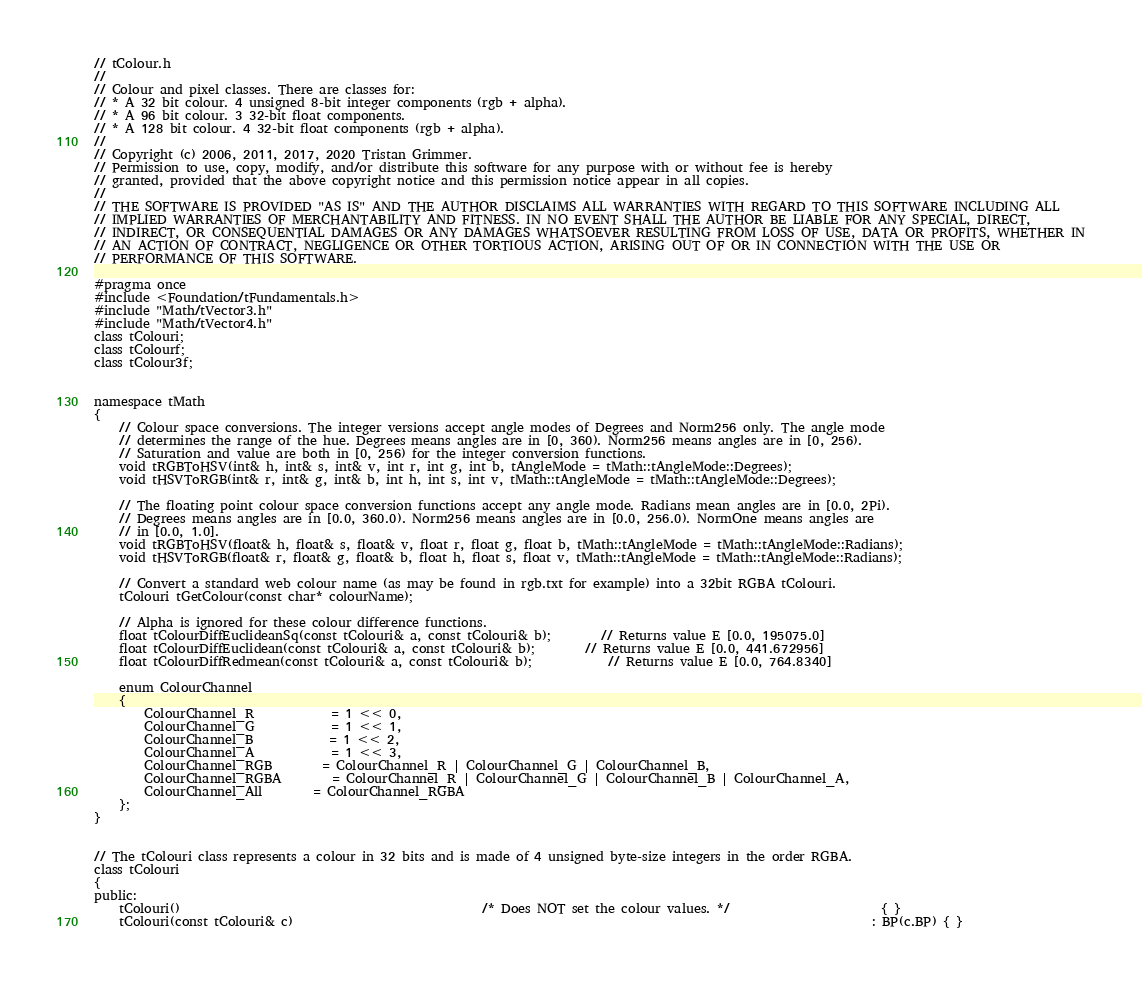<code> <loc_0><loc_0><loc_500><loc_500><_C_>// tColour.h
//
// Colour and pixel classes. There are classes for:
// * A 32 bit colour. 4 unsigned 8-bit integer components (rgb + alpha).
// * A 96 bit colour. 3 32-bit float components.
// * A 128 bit colour. 4 32-bit float components (rgb + alpha).
//
// Copyright (c) 2006, 2011, 2017, 2020 Tristan Grimmer.
// Permission to use, copy, modify, and/or distribute this software for any purpose with or without fee is hereby
// granted, provided that the above copyright notice and this permission notice appear in all copies.
//
// THE SOFTWARE IS PROVIDED "AS IS" AND THE AUTHOR DISCLAIMS ALL WARRANTIES WITH REGARD TO THIS SOFTWARE INCLUDING ALL
// IMPLIED WARRANTIES OF MERCHANTABILITY AND FITNESS. IN NO EVENT SHALL THE AUTHOR BE LIABLE FOR ANY SPECIAL, DIRECT,
// INDIRECT, OR CONSEQUENTIAL DAMAGES OR ANY DAMAGES WHATSOEVER RESULTING FROM LOSS OF USE, DATA OR PROFITS, WHETHER IN
// AN ACTION OF CONTRACT, NEGLIGENCE OR OTHER TORTIOUS ACTION, ARISING OUT OF OR IN CONNECTION WITH THE USE OR
// PERFORMANCE OF THIS SOFTWARE.

#pragma once
#include <Foundation/tFundamentals.h>
#include "Math/tVector3.h"
#include "Math/tVector4.h"
class tColouri;
class tColourf;
class tColour3f;


namespace tMath
{
	// Colour space conversions. The integer versions accept angle modes of Degrees and Norm256 only. The angle mode
	// determines the range of the hue. Degrees means angles are in [0, 360). Norm256 means angles are in [0, 256).
	// Saturation and value are both in [0, 256) for the integer conversion functions.
	void tRGBToHSV(int& h, int& s, int& v, int r, int g, int b, tAngleMode = tMath::tAngleMode::Degrees);
	void tHSVToRGB(int& r, int& g, int& b, int h, int s, int v, tMath::tAngleMode = tMath::tAngleMode::Degrees);

	// The floating point colour space conversion functions accept any angle mode. Radians mean angles are in [0.0, 2Pi).
	// Degrees means angles are in [0.0, 360.0). Norm256 means angles are in [0.0, 256.0). NormOne means angles are
	// in [0.0, 1.0].
	void tRGBToHSV(float& h, float& s, float& v, float r, float g, float b, tMath::tAngleMode = tMath::tAngleMode::Radians);
	void tHSVToRGB(float& r, float& g, float& b, float h, float s, float v, tMath::tAngleMode = tMath::tAngleMode::Radians);

	// Convert a standard web colour name (as may be found in rgb.txt for example) into a 32bit RGBA tColouri.
	tColouri tGetColour(const char* colourName);

	// Alpha is ignored for these colour difference functions.
	float tColourDiffEuclideanSq(const tColouri& a, const tColouri& b);		// Returns value E [0.0, 195075.0]
	float tColourDiffEuclidean(const tColouri& a, const tColouri& b);		// Returns value E [0.0, 441.672956]
	float tColourDiffRedmean(const tColouri& a, const tColouri& b);			// Returns value E [0.0, 764.8340]

	enum ColourChannel
	{
		ColourChannel_R			= 1 << 0,
		ColourChannel_G			= 1 << 1,
		ColourChannel_B			= 1 << 2,
		ColourChannel_A			= 1 << 3,
		ColourChannel_RGB		= ColourChannel_R | ColourChannel_G | ColourChannel_B,
		ColourChannel_RGBA		= ColourChannel_R | ColourChannel_G | ColourChannel_B | ColourChannel_A,
		ColourChannel_All		= ColourChannel_RGBA
	};
}


// The tColouri class represents a colour in 32 bits and is made of 4 unsigned byte-size integers in the order RGBA.
class tColouri
{
public:
	tColouri()												/* Does NOT set the colour values. */						{ }
	tColouri(const tColouri& c)																							: BP(c.BP) { }</code> 